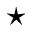<formula> <loc_0><loc_0><loc_500><loc_500>^ { ^ { * } }</formula> 